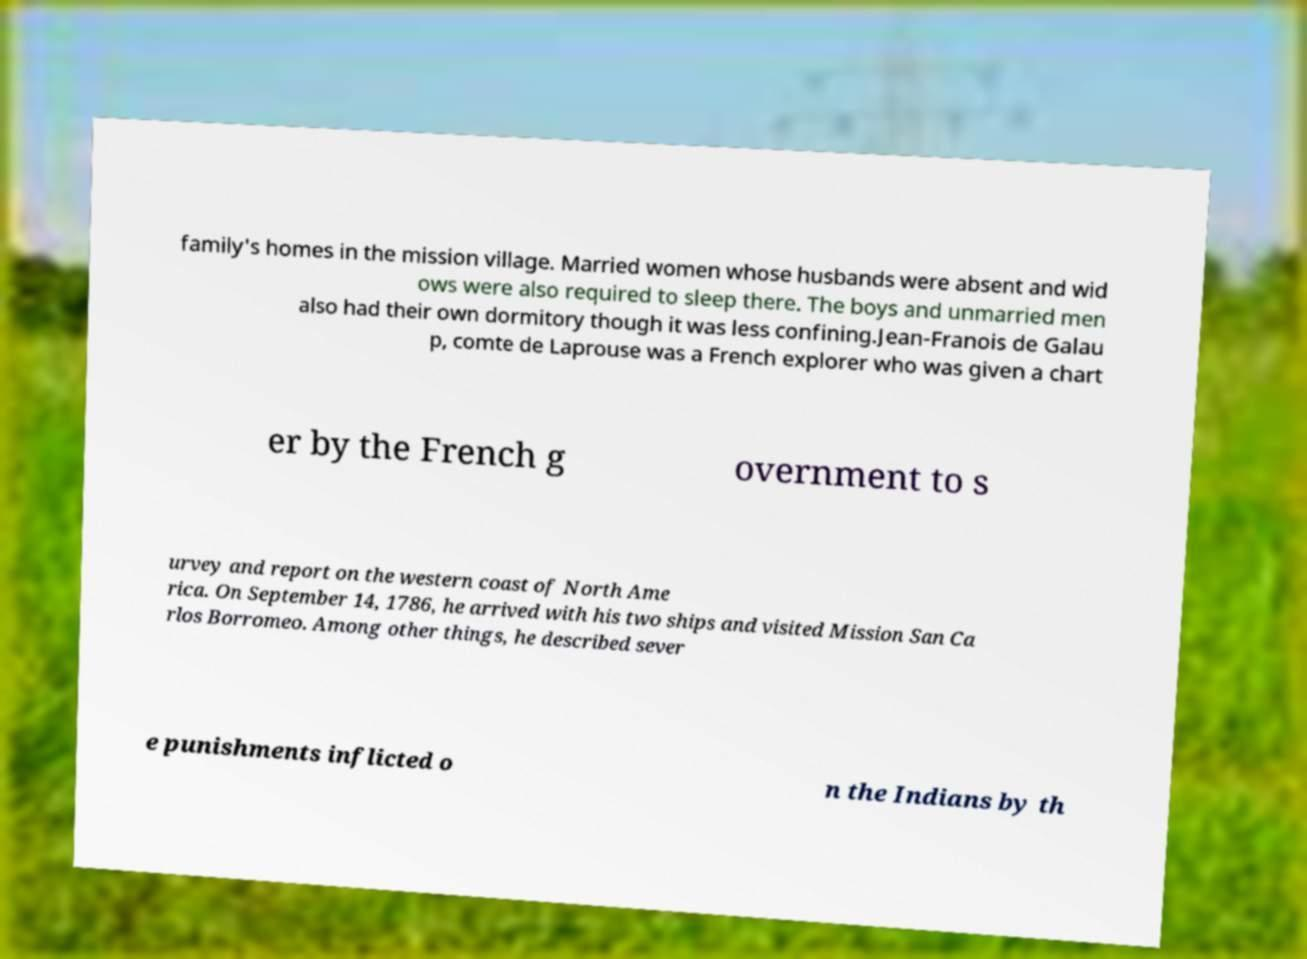Can you accurately transcribe the text from the provided image for me? family's homes in the mission village. Married women whose husbands were absent and wid ows were also required to sleep there. The boys and unmarried men also had their own dormitory though it was less confining.Jean-Franois de Galau p, comte de Laprouse was a French explorer who was given a chart er by the French g overnment to s urvey and report on the western coast of North Ame rica. On September 14, 1786, he arrived with his two ships and visited Mission San Ca rlos Borromeo. Among other things, he described sever e punishments inflicted o n the Indians by th 